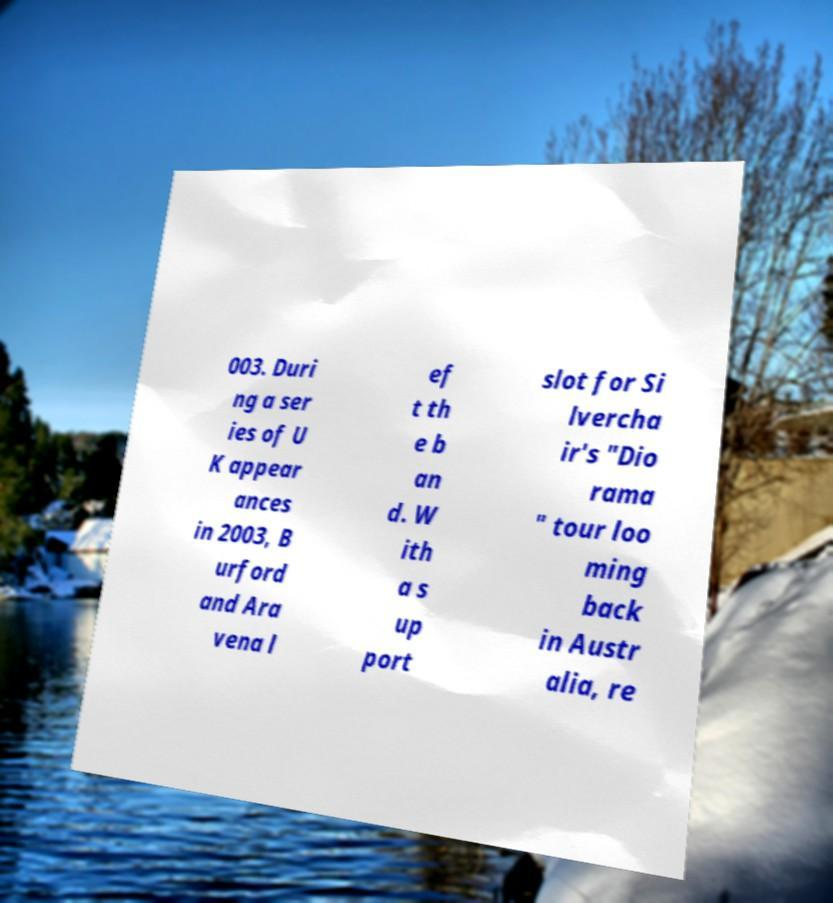For documentation purposes, I need the text within this image transcribed. Could you provide that? 003. Duri ng a ser ies of U K appear ances in 2003, B urford and Ara vena l ef t th e b an d. W ith a s up port slot for Si lvercha ir's "Dio rama " tour loo ming back in Austr alia, re 